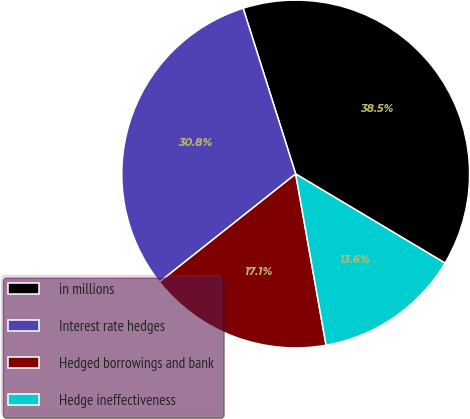Convert chart. <chart><loc_0><loc_0><loc_500><loc_500><pie_chart><fcel>in millions<fcel>Interest rate hedges<fcel>Hedged borrowings and bank<fcel>Hedge ineffectiveness<nl><fcel>38.45%<fcel>30.78%<fcel>17.13%<fcel>13.64%<nl></chart> 